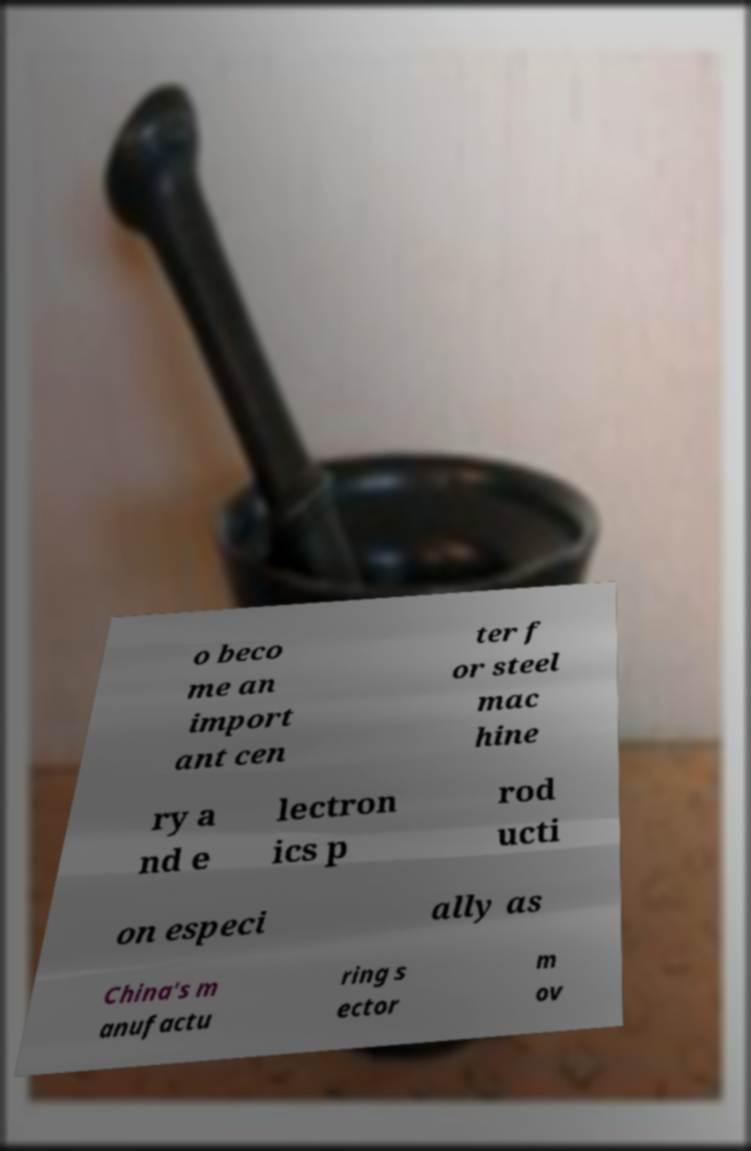For documentation purposes, I need the text within this image transcribed. Could you provide that? o beco me an import ant cen ter f or steel mac hine ry a nd e lectron ics p rod ucti on especi ally as China's m anufactu ring s ector m ov 